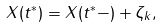<formula> <loc_0><loc_0><loc_500><loc_500>X ( t ^ { * } ) = X ( t ^ { * } - ) + \zeta _ { k } ,</formula> 